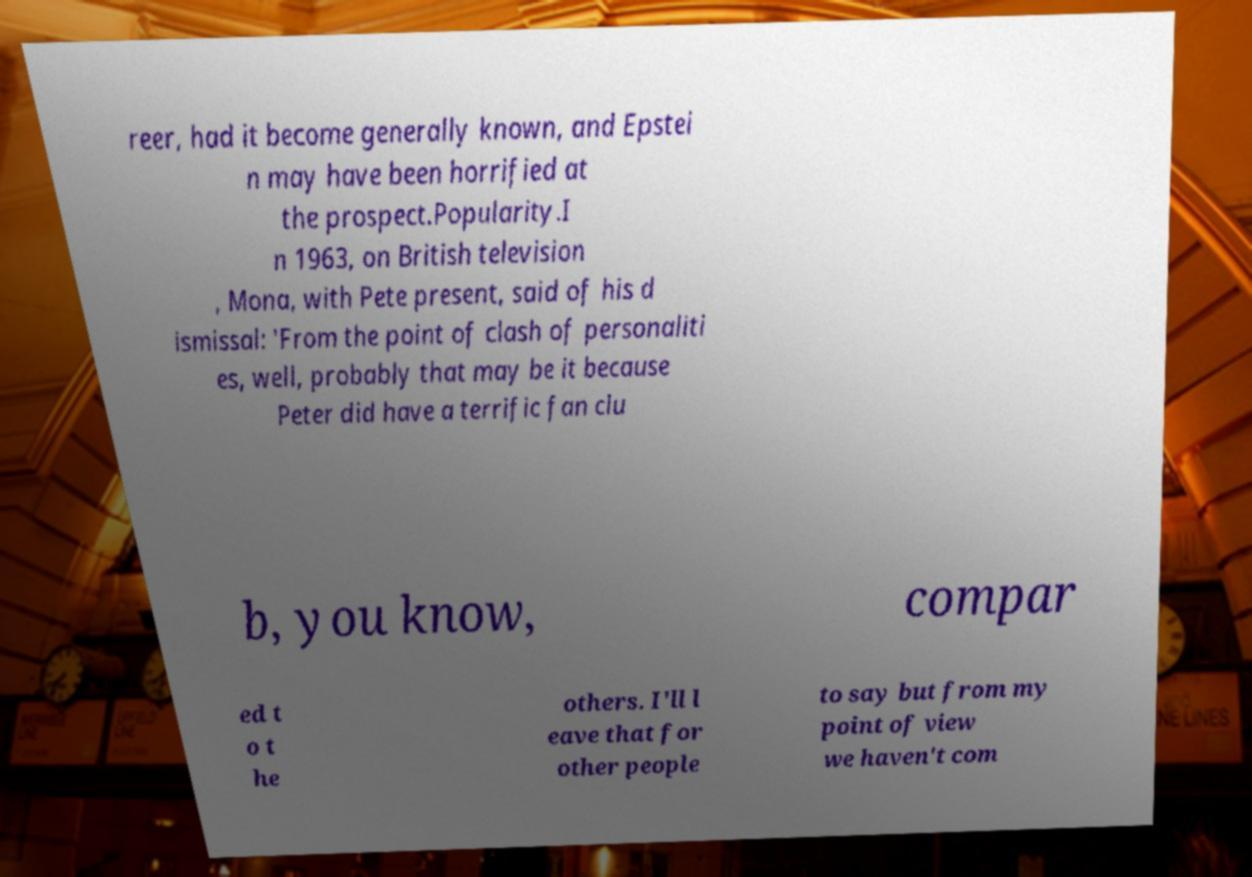There's text embedded in this image that I need extracted. Can you transcribe it verbatim? reer, had it become generally known, and Epstei n may have been horrified at the prospect.Popularity.I n 1963, on British television , Mona, with Pete present, said of his d ismissal: 'From the point of clash of personaliti es, well, probably that may be it because Peter did have a terrific fan clu b, you know, compar ed t o t he others. I'll l eave that for other people to say but from my point of view we haven't com 